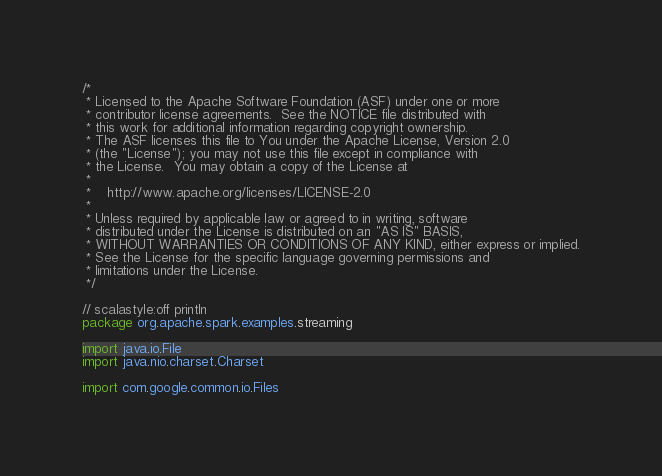<code> <loc_0><loc_0><loc_500><loc_500><_Scala_>/*
 * Licensed to the Apache Software Foundation (ASF) under one or more
 * contributor license agreements.  See the NOTICE file distributed with
 * this work for additional information regarding copyright ownership.
 * The ASF licenses this file to You under the Apache License, Version 2.0
 * (the "License"); you may not use this file except in compliance with
 * the License.  You may obtain a copy of the License at
 *
 *    http://www.apache.org/licenses/LICENSE-2.0
 *
 * Unless required by applicable law or agreed to in writing, software
 * distributed under the License is distributed on an "AS IS" BASIS,
 * WITHOUT WARRANTIES OR CONDITIONS OF ANY KIND, either express or implied.
 * See the License for the specific language governing permissions and
 * limitations under the License.
 */

// scalastyle:off println
package org.apache.spark.examples.streaming

import java.io.File
import java.nio.charset.Charset

import com.google.common.io.Files
</code> 